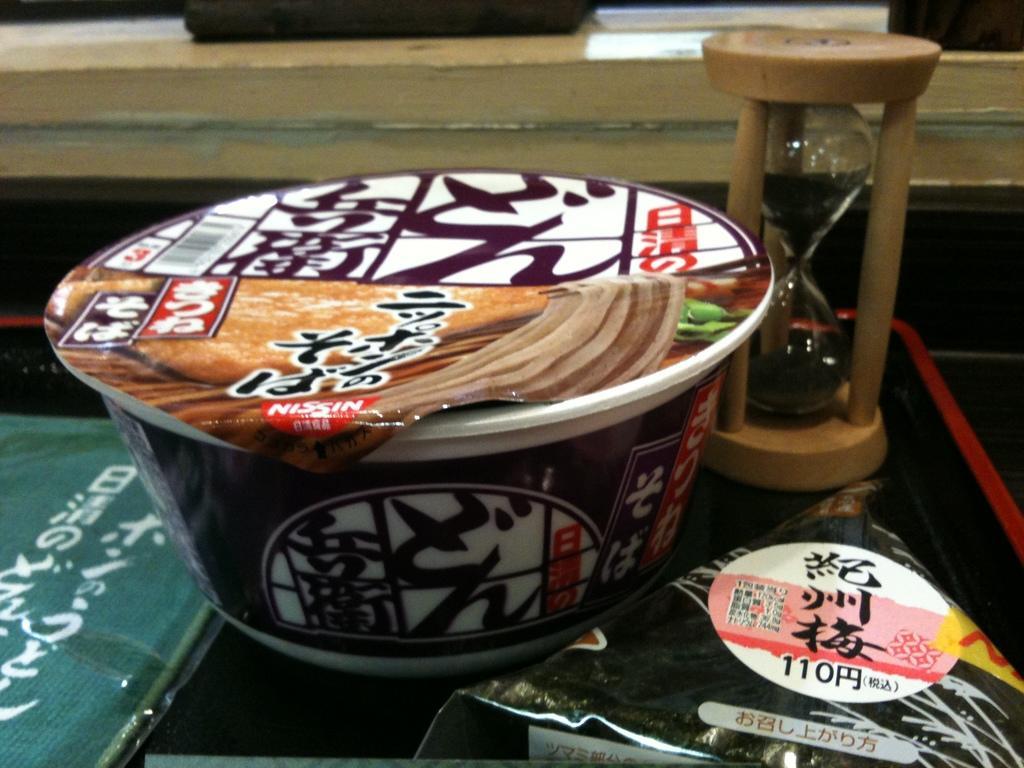How would you summarize this image in a sentence or two? In this image I can see a cup,sand timer and few objects in front. Back I can see a wood. 